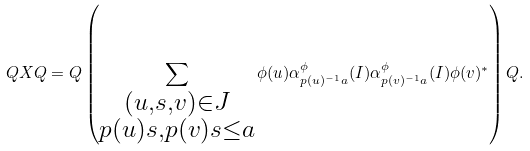Convert formula to latex. <formula><loc_0><loc_0><loc_500><loc_500>Q X Q = Q \left ( \sum _ { \substack { ( u , s , v ) \in J \\ p ( u ) s , p ( v ) s \leq a } } \phi ( u ) \alpha ^ { \phi } _ { p ( u ) ^ { - 1 } a } ( I ) \alpha ^ { \phi } _ { p ( v ) ^ { - 1 } a } ( I ) \phi ( v ) ^ { * } \right ) Q .</formula> 